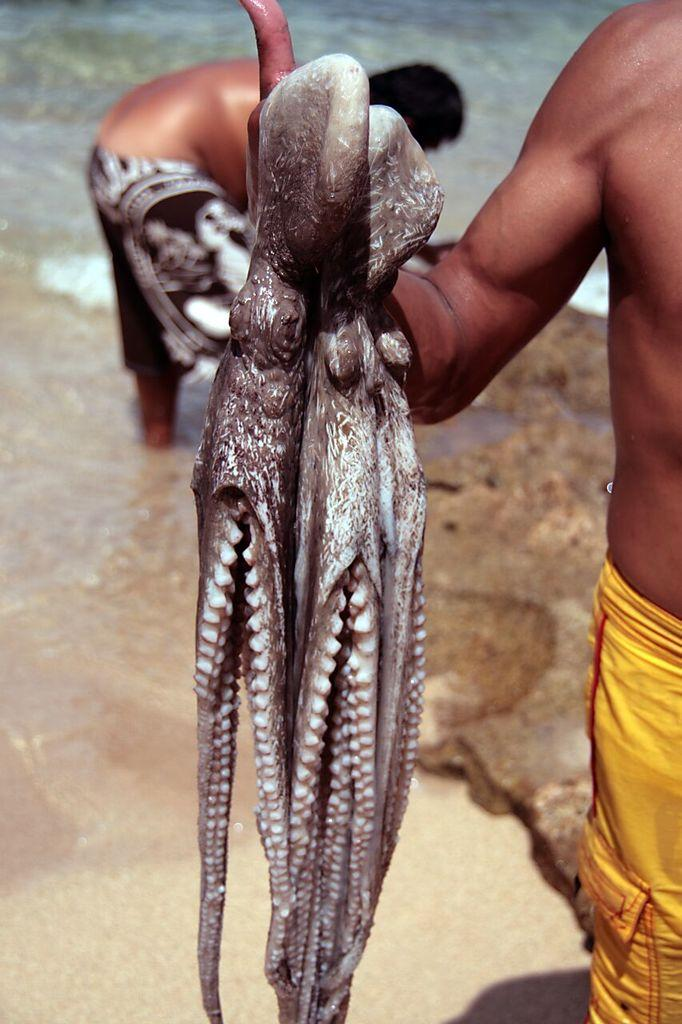What is the person in the image holding? The person is holding a starfish in the image. What type of surface is visible in the image? There is sand visible in the image. Can you describe the background of the image? There is a person in the background of the image, and water is visible in the background as well. What type of ornament is hanging from the starfish in the image? There is no ornament hanging from the starfish in the image; the person is simply holding a starfish. What color is the chalk used to draw on the sand in the image? There is no chalk or drawing on the sand in the image; it only shows a person holding a starfish and the sandy background. 